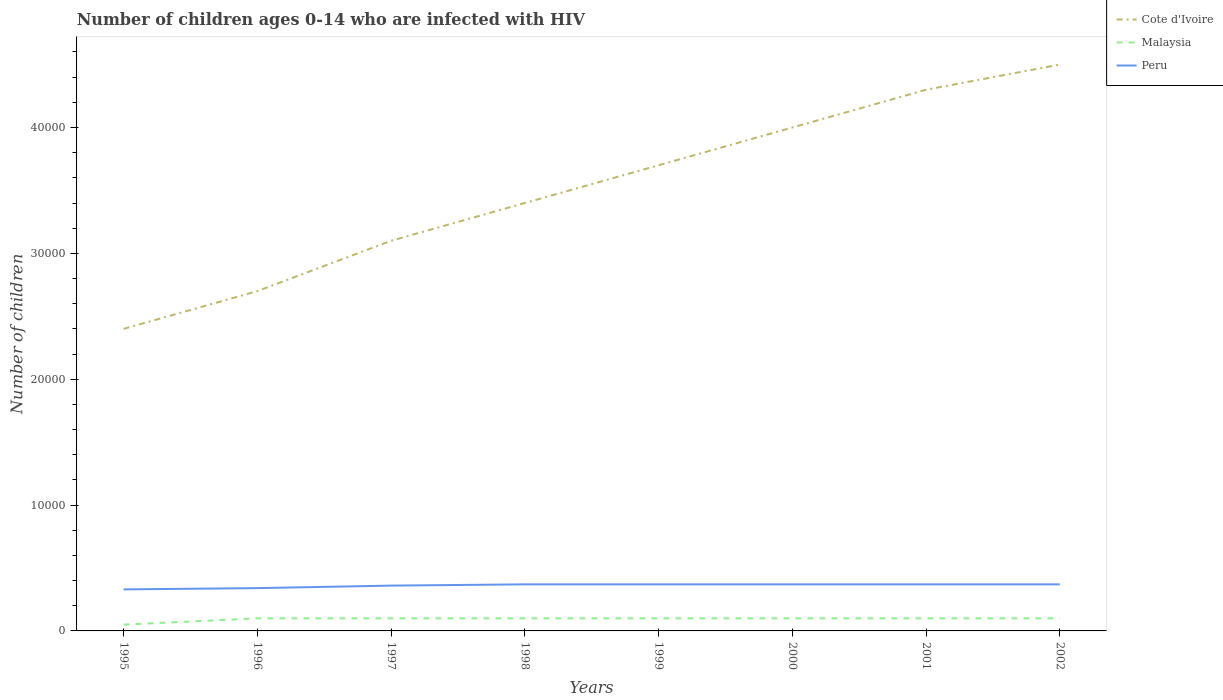Does the line corresponding to Peru intersect with the line corresponding to Cote d'Ivoire?
Your response must be concise. No. Across all years, what is the maximum number of HIV infected children in Peru?
Your response must be concise. 3300. What is the total number of HIV infected children in Peru in the graph?
Make the answer very short. -300. What is the difference between the highest and the second highest number of HIV infected children in Malaysia?
Make the answer very short. 500. What is the difference between the highest and the lowest number of HIV infected children in Peru?
Provide a succinct answer. 5. Is the number of HIV infected children in Peru strictly greater than the number of HIV infected children in Cote d'Ivoire over the years?
Make the answer very short. Yes. Are the values on the major ticks of Y-axis written in scientific E-notation?
Your answer should be compact. No. Does the graph contain any zero values?
Your response must be concise. No. Does the graph contain grids?
Your answer should be very brief. No. Where does the legend appear in the graph?
Offer a terse response. Top right. What is the title of the graph?
Your answer should be very brief. Number of children ages 0-14 who are infected with HIV. What is the label or title of the X-axis?
Your response must be concise. Years. What is the label or title of the Y-axis?
Provide a succinct answer. Number of children. What is the Number of children in Cote d'Ivoire in 1995?
Your answer should be compact. 2.40e+04. What is the Number of children of Malaysia in 1995?
Your answer should be very brief. 500. What is the Number of children in Peru in 1995?
Your answer should be compact. 3300. What is the Number of children in Cote d'Ivoire in 1996?
Your answer should be very brief. 2.70e+04. What is the Number of children of Peru in 1996?
Make the answer very short. 3400. What is the Number of children of Cote d'Ivoire in 1997?
Keep it short and to the point. 3.10e+04. What is the Number of children in Peru in 1997?
Give a very brief answer. 3600. What is the Number of children of Cote d'Ivoire in 1998?
Give a very brief answer. 3.40e+04. What is the Number of children of Peru in 1998?
Your answer should be compact. 3700. What is the Number of children of Cote d'Ivoire in 1999?
Provide a succinct answer. 3.70e+04. What is the Number of children in Malaysia in 1999?
Offer a very short reply. 1000. What is the Number of children in Peru in 1999?
Provide a short and direct response. 3700. What is the Number of children of Malaysia in 2000?
Give a very brief answer. 1000. What is the Number of children of Peru in 2000?
Your answer should be compact. 3700. What is the Number of children in Cote d'Ivoire in 2001?
Offer a terse response. 4.30e+04. What is the Number of children in Peru in 2001?
Your answer should be compact. 3700. What is the Number of children in Cote d'Ivoire in 2002?
Make the answer very short. 4.50e+04. What is the Number of children in Peru in 2002?
Offer a terse response. 3700. Across all years, what is the maximum Number of children in Cote d'Ivoire?
Your answer should be compact. 4.50e+04. Across all years, what is the maximum Number of children in Malaysia?
Make the answer very short. 1000. Across all years, what is the maximum Number of children in Peru?
Make the answer very short. 3700. Across all years, what is the minimum Number of children in Cote d'Ivoire?
Your answer should be very brief. 2.40e+04. Across all years, what is the minimum Number of children of Peru?
Provide a succinct answer. 3300. What is the total Number of children of Cote d'Ivoire in the graph?
Provide a short and direct response. 2.81e+05. What is the total Number of children in Malaysia in the graph?
Your answer should be very brief. 7500. What is the total Number of children in Peru in the graph?
Provide a succinct answer. 2.88e+04. What is the difference between the Number of children in Cote d'Ivoire in 1995 and that in 1996?
Give a very brief answer. -3000. What is the difference between the Number of children in Malaysia in 1995 and that in 1996?
Your answer should be compact. -500. What is the difference between the Number of children of Peru in 1995 and that in 1996?
Offer a very short reply. -100. What is the difference between the Number of children in Cote d'Ivoire in 1995 and that in 1997?
Make the answer very short. -7000. What is the difference between the Number of children of Malaysia in 1995 and that in 1997?
Your answer should be compact. -500. What is the difference between the Number of children of Peru in 1995 and that in 1997?
Give a very brief answer. -300. What is the difference between the Number of children in Cote d'Ivoire in 1995 and that in 1998?
Make the answer very short. -10000. What is the difference between the Number of children in Malaysia in 1995 and that in 1998?
Ensure brevity in your answer.  -500. What is the difference between the Number of children in Peru in 1995 and that in 1998?
Ensure brevity in your answer.  -400. What is the difference between the Number of children of Cote d'Ivoire in 1995 and that in 1999?
Provide a short and direct response. -1.30e+04. What is the difference between the Number of children in Malaysia in 1995 and that in 1999?
Provide a short and direct response. -500. What is the difference between the Number of children of Peru in 1995 and that in 1999?
Offer a terse response. -400. What is the difference between the Number of children in Cote d'Ivoire in 1995 and that in 2000?
Keep it short and to the point. -1.60e+04. What is the difference between the Number of children of Malaysia in 1995 and that in 2000?
Keep it short and to the point. -500. What is the difference between the Number of children of Peru in 1995 and that in 2000?
Provide a short and direct response. -400. What is the difference between the Number of children in Cote d'Ivoire in 1995 and that in 2001?
Keep it short and to the point. -1.90e+04. What is the difference between the Number of children of Malaysia in 1995 and that in 2001?
Give a very brief answer. -500. What is the difference between the Number of children in Peru in 1995 and that in 2001?
Provide a short and direct response. -400. What is the difference between the Number of children in Cote d'Ivoire in 1995 and that in 2002?
Offer a terse response. -2.10e+04. What is the difference between the Number of children in Malaysia in 1995 and that in 2002?
Keep it short and to the point. -500. What is the difference between the Number of children of Peru in 1995 and that in 2002?
Offer a terse response. -400. What is the difference between the Number of children in Cote d'Ivoire in 1996 and that in 1997?
Keep it short and to the point. -4000. What is the difference between the Number of children in Malaysia in 1996 and that in 1997?
Give a very brief answer. 0. What is the difference between the Number of children in Peru in 1996 and that in 1997?
Make the answer very short. -200. What is the difference between the Number of children of Cote d'Ivoire in 1996 and that in 1998?
Your answer should be very brief. -7000. What is the difference between the Number of children of Peru in 1996 and that in 1998?
Your answer should be very brief. -300. What is the difference between the Number of children in Peru in 1996 and that in 1999?
Provide a succinct answer. -300. What is the difference between the Number of children in Cote d'Ivoire in 1996 and that in 2000?
Keep it short and to the point. -1.30e+04. What is the difference between the Number of children in Malaysia in 1996 and that in 2000?
Your response must be concise. 0. What is the difference between the Number of children of Peru in 1996 and that in 2000?
Your response must be concise. -300. What is the difference between the Number of children of Cote d'Ivoire in 1996 and that in 2001?
Your answer should be very brief. -1.60e+04. What is the difference between the Number of children in Peru in 1996 and that in 2001?
Your answer should be very brief. -300. What is the difference between the Number of children of Cote d'Ivoire in 1996 and that in 2002?
Ensure brevity in your answer.  -1.80e+04. What is the difference between the Number of children of Peru in 1996 and that in 2002?
Keep it short and to the point. -300. What is the difference between the Number of children of Cote d'Ivoire in 1997 and that in 1998?
Your answer should be compact. -3000. What is the difference between the Number of children in Malaysia in 1997 and that in 1998?
Make the answer very short. 0. What is the difference between the Number of children in Peru in 1997 and that in 1998?
Provide a short and direct response. -100. What is the difference between the Number of children in Cote d'Ivoire in 1997 and that in 1999?
Keep it short and to the point. -6000. What is the difference between the Number of children of Malaysia in 1997 and that in 1999?
Provide a succinct answer. 0. What is the difference between the Number of children of Peru in 1997 and that in 1999?
Ensure brevity in your answer.  -100. What is the difference between the Number of children in Cote d'Ivoire in 1997 and that in 2000?
Keep it short and to the point. -9000. What is the difference between the Number of children in Peru in 1997 and that in 2000?
Ensure brevity in your answer.  -100. What is the difference between the Number of children in Cote d'Ivoire in 1997 and that in 2001?
Keep it short and to the point. -1.20e+04. What is the difference between the Number of children in Peru in 1997 and that in 2001?
Your response must be concise. -100. What is the difference between the Number of children of Cote d'Ivoire in 1997 and that in 2002?
Keep it short and to the point. -1.40e+04. What is the difference between the Number of children of Malaysia in 1997 and that in 2002?
Your answer should be compact. 0. What is the difference between the Number of children of Peru in 1997 and that in 2002?
Make the answer very short. -100. What is the difference between the Number of children in Cote d'Ivoire in 1998 and that in 1999?
Provide a succinct answer. -3000. What is the difference between the Number of children of Malaysia in 1998 and that in 1999?
Give a very brief answer. 0. What is the difference between the Number of children in Peru in 1998 and that in 1999?
Provide a succinct answer. 0. What is the difference between the Number of children of Cote d'Ivoire in 1998 and that in 2000?
Your answer should be compact. -6000. What is the difference between the Number of children in Peru in 1998 and that in 2000?
Provide a succinct answer. 0. What is the difference between the Number of children of Cote d'Ivoire in 1998 and that in 2001?
Provide a succinct answer. -9000. What is the difference between the Number of children in Malaysia in 1998 and that in 2001?
Offer a terse response. 0. What is the difference between the Number of children in Cote d'Ivoire in 1998 and that in 2002?
Keep it short and to the point. -1.10e+04. What is the difference between the Number of children in Malaysia in 1998 and that in 2002?
Offer a very short reply. 0. What is the difference between the Number of children in Cote d'Ivoire in 1999 and that in 2000?
Make the answer very short. -3000. What is the difference between the Number of children of Peru in 1999 and that in 2000?
Offer a very short reply. 0. What is the difference between the Number of children of Cote d'Ivoire in 1999 and that in 2001?
Offer a very short reply. -6000. What is the difference between the Number of children in Malaysia in 1999 and that in 2001?
Your response must be concise. 0. What is the difference between the Number of children in Peru in 1999 and that in 2001?
Make the answer very short. 0. What is the difference between the Number of children of Cote d'Ivoire in 1999 and that in 2002?
Provide a short and direct response. -8000. What is the difference between the Number of children of Peru in 1999 and that in 2002?
Ensure brevity in your answer.  0. What is the difference between the Number of children of Cote d'Ivoire in 2000 and that in 2001?
Provide a succinct answer. -3000. What is the difference between the Number of children of Malaysia in 2000 and that in 2001?
Offer a terse response. 0. What is the difference between the Number of children in Cote d'Ivoire in 2000 and that in 2002?
Provide a short and direct response. -5000. What is the difference between the Number of children of Malaysia in 2000 and that in 2002?
Keep it short and to the point. 0. What is the difference between the Number of children of Peru in 2000 and that in 2002?
Give a very brief answer. 0. What is the difference between the Number of children in Cote d'Ivoire in 2001 and that in 2002?
Ensure brevity in your answer.  -2000. What is the difference between the Number of children of Peru in 2001 and that in 2002?
Give a very brief answer. 0. What is the difference between the Number of children of Cote d'Ivoire in 1995 and the Number of children of Malaysia in 1996?
Provide a succinct answer. 2.30e+04. What is the difference between the Number of children of Cote d'Ivoire in 1995 and the Number of children of Peru in 1996?
Your answer should be very brief. 2.06e+04. What is the difference between the Number of children of Malaysia in 1995 and the Number of children of Peru in 1996?
Offer a terse response. -2900. What is the difference between the Number of children of Cote d'Ivoire in 1995 and the Number of children of Malaysia in 1997?
Provide a succinct answer. 2.30e+04. What is the difference between the Number of children of Cote d'Ivoire in 1995 and the Number of children of Peru in 1997?
Provide a short and direct response. 2.04e+04. What is the difference between the Number of children of Malaysia in 1995 and the Number of children of Peru in 1997?
Your answer should be very brief. -3100. What is the difference between the Number of children of Cote d'Ivoire in 1995 and the Number of children of Malaysia in 1998?
Ensure brevity in your answer.  2.30e+04. What is the difference between the Number of children in Cote d'Ivoire in 1995 and the Number of children in Peru in 1998?
Offer a terse response. 2.03e+04. What is the difference between the Number of children of Malaysia in 1995 and the Number of children of Peru in 1998?
Ensure brevity in your answer.  -3200. What is the difference between the Number of children in Cote d'Ivoire in 1995 and the Number of children in Malaysia in 1999?
Offer a very short reply. 2.30e+04. What is the difference between the Number of children of Cote d'Ivoire in 1995 and the Number of children of Peru in 1999?
Your answer should be very brief. 2.03e+04. What is the difference between the Number of children of Malaysia in 1995 and the Number of children of Peru in 1999?
Your answer should be compact. -3200. What is the difference between the Number of children of Cote d'Ivoire in 1995 and the Number of children of Malaysia in 2000?
Offer a terse response. 2.30e+04. What is the difference between the Number of children in Cote d'Ivoire in 1995 and the Number of children in Peru in 2000?
Your answer should be very brief. 2.03e+04. What is the difference between the Number of children of Malaysia in 1995 and the Number of children of Peru in 2000?
Your answer should be very brief. -3200. What is the difference between the Number of children of Cote d'Ivoire in 1995 and the Number of children of Malaysia in 2001?
Your answer should be compact. 2.30e+04. What is the difference between the Number of children of Cote d'Ivoire in 1995 and the Number of children of Peru in 2001?
Provide a short and direct response. 2.03e+04. What is the difference between the Number of children in Malaysia in 1995 and the Number of children in Peru in 2001?
Give a very brief answer. -3200. What is the difference between the Number of children in Cote d'Ivoire in 1995 and the Number of children in Malaysia in 2002?
Provide a short and direct response. 2.30e+04. What is the difference between the Number of children in Cote d'Ivoire in 1995 and the Number of children in Peru in 2002?
Your answer should be very brief. 2.03e+04. What is the difference between the Number of children in Malaysia in 1995 and the Number of children in Peru in 2002?
Your answer should be compact. -3200. What is the difference between the Number of children in Cote d'Ivoire in 1996 and the Number of children in Malaysia in 1997?
Offer a very short reply. 2.60e+04. What is the difference between the Number of children of Cote d'Ivoire in 1996 and the Number of children of Peru in 1997?
Ensure brevity in your answer.  2.34e+04. What is the difference between the Number of children of Malaysia in 1996 and the Number of children of Peru in 1997?
Provide a succinct answer. -2600. What is the difference between the Number of children of Cote d'Ivoire in 1996 and the Number of children of Malaysia in 1998?
Ensure brevity in your answer.  2.60e+04. What is the difference between the Number of children in Cote d'Ivoire in 1996 and the Number of children in Peru in 1998?
Keep it short and to the point. 2.33e+04. What is the difference between the Number of children of Malaysia in 1996 and the Number of children of Peru in 1998?
Provide a short and direct response. -2700. What is the difference between the Number of children of Cote d'Ivoire in 1996 and the Number of children of Malaysia in 1999?
Ensure brevity in your answer.  2.60e+04. What is the difference between the Number of children in Cote d'Ivoire in 1996 and the Number of children in Peru in 1999?
Give a very brief answer. 2.33e+04. What is the difference between the Number of children of Malaysia in 1996 and the Number of children of Peru in 1999?
Your response must be concise. -2700. What is the difference between the Number of children in Cote d'Ivoire in 1996 and the Number of children in Malaysia in 2000?
Your answer should be very brief. 2.60e+04. What is the difference between the Number of children in Cote d'Ivoire in 1996 and the Number of children in Peru in 2000?
Your answer should be very brief. 2.33e+04. What is the difference between the Number of children in Malaysia in 1996 and the Number of children in Peru in 2000?
Your answer should be compact. -2700. What is the difference between the Number of children of Cote d'Ivoire in 1996 and the Number of children of Malaysia in 2001?
Offer a very short reply. 2.60e+04. What is the difference between the Number of children of Cote d'Ivoire in 1996 and the Number of children of Peru in 2001?
Keep it short and to the point. 2.33e+04. What is the difference between the Number of children in Malaysia in 1996 and the Number of children in Peru in 2001?
Provide a succinct answer. -2700. What is the difference between the Number of children of Cote d'Ivoire in 1996 and the Number of children of Malaysia in 2002?
Your response must be concise. 2.60e+04. What is the difference between the Number of children of Cote d'Ivoire in 1996 and the Number of children of Peru in 2002?
Make the answer very short. 2.33e+04. What is the difference between the Number of children of Malaysia in 1996 and the Number of children of Peru in 2002?
Ensure brevity in your answer.  -2700. What is the difference between the Number of children in Cote d'Ivoire in 1997 and the Number of children in Malaysia in 1998?
Give a very brief answer. 3.00e+04. What is the difference between the Number of children in Cote d'Ivoire in 1997 and the Number of children in Peru in 1998?
Your answer should be compact. 2.73e+04. What is the difference between the Number of children of Malaysia in 1997 and the Number of children of Peru in 1998?
Offer a very short reply. -2700. What is the difference between the Number of children in Cote d'Ivoire in 1997 and the Number of children in Malaysia in 1999?
Keep it short and to the point. 3.00e+04. What is the difference between the Number of children in Cote d'Ivoire in 1997 and the Number of children in Peru in 1999?
Offer a very short reply. 2.73e+04. What is the difference between the Number of children in Malaysia in 1997 and the Number of children in Peru in 1999?
Your answer should be very brief. -2700. What is the difference between the Number of children in Cote d'Ivoire in 1997 and the Number of children in Peru in 2000?
Give a very brief answer. 2.73e+04. What is the difference between the Number of children of Malaysia in 1997 and the Number of children of Peru in 2000?
Provide a short and direct response. -2700. What is the difference between the Number of children in Cote d'Ivoire in 1997 and the Number of children in Malaysia in 2001?
Ensure brevity in your answer.  3.00e+04. What is the difference between the Number of children of Cote d'Ivoire in 1997 and the Number of children of Peru in 2001?
Give a very brief answer. 2.73e+04. What is the difference between the Number of children of Malaysia in 1997 and the Number of children of Peru in 2001?
Your answer should be very brief. -2700. What is the difference between the Number of children in Cote d'Ivoire in 1997 and the Number of children in Malaysia in 2002?
Ensure brevity in your answer.  3.00e+04. What is the difference between the Number of children in Cote d'Ivoire in 1997 and the Number of children in Peru in 2002?
Offer a very short reply. 2.73e+04. What is the difference between the Number of children of Malaysia in 1997 and the Number of children of Peru in 2002?
Your answer should be very brief. -2700. What is the difference between the Number of children of Cote d'Ivoire in 1998 and the Number of children of Malaysia in 1999?
Give a very brief answer. 3.30e+04. What is the difference between the Number of children of Cote d'Ivoire in 1998 and the Number of children of Peru in 1999?
Your answer should be very brief. 3.03e+04. What is the difference between the Number of children in Malaysia in 1998 and the Number of children in Peru in 1999?
Your answer should be very brief. -2700. What is the difference between the Number of children of Cote d'Ivoire in 1998 and the Number of children of Malaysia in 2000?
Give a very brief answer. 3.30e+04. What is the difference between the Number of children of Cote d'Ivoire in 1998 and the Number of children of Peru in 2000?
Make the answer very short. 3.03e+04. What is the difference between the Number of children in Malaysia in 1998 and the Number of children in Peru in 2000?
Make the answer very short. -2700. What is the difference between the Number of children in Cote d'Ivoire in 1998 and the Number of children in Malaysia in 2001?
Your answer should be compact. 3.30e+04. What is the difference between the Number of children in Cote d'Ivoire in 1998 and the Number of children in Peru in 2001?
Offer a terse response. 3.03e+04. What is the difference between the Number of children of Malaysia in 1998 and the Number of children of Peru in 2001?
Offer a terse response. -2700. What is the difference between the Number of children of Cote d'Ivoire in 1998 and the Number of children of Malaysia in 2002?
Keep it short and to the point. 3.30e+04. What is the difference between the Number of children in Cote d'Ivoire in 1998 and the Number of children in Peru in 2002?
Keep it short and to the point. 3.03e+04. What is the difference between the Number of children in Malaysia in 1998 and the Number of children in Peru in 2002?
Offer a very short reply. -2700. What is the difference between the Number of children in Cote d'Ivoire in 1999 and the Number of children in Malaysia in 2000?
Your answer should be compact. 3.60e+04. What is the difference between the Number of children in Cote d'Ivoire in 1999 and the Number of children in Peru in 2000?
Your answer should be compact. 3.33e+04. What is the difference between the Number of children in Malaysia in 1999 and the Number of children in Peru in 2000?
Your answer should be compact. -2700. What is the difference between the Number of children in Cote d'Ivoire in 1999 and the Number of children in Malaysia in 2001?
Your answer should be very brief. 3.60e+04. What is the difference between the Number of children of Cote d'Ivoire in 1999 and the Number of children of Peru in 2001?
Your response must be concise. 3.33e+04. What is the difference between the Number of children in Malaysia in 1999 and the Number of children in Peru in 2001?
Provide a short and direct response. -2700. What is the difference between the Number of children of Cote d'Ivoire in 1999 and the Number of children of Malaysia in 2002?
Offer a terse response. 3.60e+04. What is the difference between the Number of children of Cote d'Ivoire in 1999 and the Number of children of Peru in 2002?
Offer a very short reply. 3.33e+04. What is the difference between the Number of children in Malaysia in 1999 and the Number of children in Peru in 2002?
Offer a very short reply. -2700. What is the difference between the Number of children in Cote d'Ivoire in 2000 and the Number of children in Malaysia in 2001?
Your answer should be very brief. 3.90e+04. What is the difference between the Number of children in Cote d'Ivoire in 2000 and the Number of children in Peru in 2001?
Your answer should be compact. 3.63e+04. What is the difference between the Number of children of Malaysia in 2000 and the Number of children of Peru in 2001?
Your answer should be very brief. -2700. What is the difference between the Number of children in Cote d'Ivoire in 2000 and the Number of children in Malaysia in 2002?
Keep it short and to the point. 3.90e+04. What is the difference between the Number of children in Cote d'Ivoire in 2000 and the Number of children in Peru in 2002?
Your response must be concise. 3.63e+04. What is the difference between the Number of children in Malaysia in 2000 and the Number of children in Peru in 2002?
Your answer should be very brief. -2700. What is the difference between the Number of children in Cote d'Ivoire in 2001 and the Number of children in Malaysia in 2002?
Keep it short and to the point. 4.20e+04. What is the difference between the Number of children in Cote d'Ivoire in 2001 and the Number of children in Peru in 2002?
Your answer should be very brief. 3.93e+04. What is the difference between the Number of children of Malaysia in 2001 and the Number of children of Peru in 2002?
Ensure brevity in your answer.  -2700. What is the average Number of children of Cote d'Ivoire per year?
Your answer should be very brief. 3.51e+04. What is the average Number of children of Malaysia per year?
Provide a succinct answer. 937.5. What is the average Number of children of Peru per year?
Provide a short and direct response. 3600. In the year 1995, what is the difference between the Number of children in Cote d'Ivoire and Number of children in Malaysia?
Give a very brief answer. 2.35e+04. In the year 1995, what is the difference between the Number of children in Cote d'Ivoire and Number of children in Peru?
Offer a terse response. 2.07e+04. In the year 1995, what is the difference between the Number of children of Malaysia and Number of children of Peru?
Provide a succinct answer. -2800. In the year 1996, what is the difference between the Number of children in Cote d'Ivoire and Number of children in Malaysia?
Offer a terse response. 2.60e+04. In the year 1996, what is the difference between the Number of children in Cote d'Ivoire and Number of children in Peru?
Offer a very short reply. 2.36e+04. In the year 1996, what is the difference between the Number of children of Malaysia and Number of children of Peru?
Provide a succinct answer. -2400. In the year 1997, what is the difference between the Number of children of Cote d'Ivoire and Number of children of Malaysia?
Provide a short and direct response. 3.00e+04. In the year 1997, what is the difference between the Number of children in Cote d'Ivoire and Number of children in Peru?
Keep it short and to the point. 2.74e+04. In the year 1997, what is the difference between the Number of children in Malaysia and Number of children in Peru?
Provide a short and direct response. -2600. In the year 1998, what is the difference between the Number of children in Cote d'Ivoire and Number of children in Malaysia?
Provide a succinct answer. 3.30e+04. In the year 1998, what is the difference between the Number of children of Cote d'Ivoire and Number of children of Peru?
Ensure brevity in your answer.  3.03e+04. In the year 1998, what is the difference between the Number of children in Malaysia and Number of children in Peru?
Offer a very short reply. -2700. In the year 1999, what is the difference between the Number of children in Cote d'Ivoire and Number of children in Malaysia?
Your answer should be very brief. 3.60e+04. In the year 1999, what is the difference between the Number of children in Cote d'Ivoire and Number of children in Peru?
Offer a very short reply. 3.33e+04. In the year 1999, what is the difference between the Number of children of Malaysia and Number of children of Peru?
Your response must be concise. -2700. In the year 2000, what is the difference between the Number of children of Cote d'Ivoire and Number of children of Malaysia?
Keep it short and to the point. 3.90e+04. In the year 2000, what is the difference between the Number of children of Cote d'Ivoire and Number of children of Peru?
Provide a short and direct response. 3.63e+04. In the year 2000, what is the difference between the Number of children in Malaysia and Number of children in Peru?
Offer a very short reply. -2700. In the year 2001, what is the difference between the Number of children of Cote d'Ivoire and Number of children of Malaysia?
Make the answer very short. 4.20e+04. In the year 2001, what is the difference between the Number of children of Cote d'Ivoire and Number of children of Peru?
Keep it short and to the point. 3.93e+04. In the year 2001, what is the difference between the Number of children of Malaysia and Number of children of Peru?
Offer a very short reply. -2700. In the year 2002, what is the difference between the Number of children of Cote d'Ivoire and Number of children of Malaysia?
Provide a succinct answer. 4.40e+04. In the year 2002, what is the difference between the Number of children of Cote d'Ivoire and Number of children of Peru?
Make the answer very short. 4.13e+04. In the year 2002, what is the difference between the Number of children in Malaysia and Number of children in Peru?
Give a very brief answer. -2700. What is the ratio of the Number of children of Cote d'Ivoire in 1995 to that in 1996?
Provide a succinct answer. 0.89. What is the ratio of the Number of children in Malaysia in 1995 to that in 1996?
Provide a succinct answer. 0.5. What is the ratio of the Number of children in Peru in 1995 to that in 1996?
Keep it short and to the point. 0.97. What is the ratio of the Number of children of Cote d'Ivoire in 1995 to that in 1997?
Give a very brief answer. 0.77. What is the ratio of the Number of children in Malaysia in 1995 to that in 1997?
Provide a short and direct response. 0.5. What is the ratio of the Number of children in Peru in 1995 to that in 1997?
Ensure brevity in your answer.  0.92. What is the ratio of the Number of children of Cote d'Ivoire in 1995 to that in 1998?
Offer a very short reply. 0.71. What is the ratio of the Number of children in Malaysia in 1995 to that in 1998?
Provide a succinct answer. 0.5. What is the ratio of the Number of children in Peru in 1995 to that in 1998?
Provide a short and direct response. 0.89. What is the ratio of the Number of children in Cote d'Ivoire in 1995 to that in 1999?
Your answer should be compact. 0.65. What is the ratio of the Number of children in Malaysia in 1995 to that in 1999?
Provide a short and direct response. 0.5. What is the ratio of the Number of children in Peru in 1995 to that in 1999?
Your response must be concise. 0.89. What is the ratio of the Number of children of Peru in 1995 to that in 2000?
Give a very brief answer. 0.89. What is the ratio of the Number of children of Cote d'Ivoire in 1995 to that in 2001?
Ensure brevity in your answer.  0.56. What is the ratio of the Number of children of Peru in 1995 to that in 2001?
Make the answer very short. 0.89. What is the ratio of the Number of children of Cote d'Ivoire in 1995 to that in 2002?
Ensure brevity in your answer.  0.53. What is the ratio of the Number of children of Peru in 1995 to that in 2002?
Provide a succinct answer. 0.89. What is the ratio of the Number of children in Cote d'Ivoire in 1996 to that in 1997?
Your response must be concise. 0.87. What is the ratio of the Number of children of Malaysia in 1996 to that in 1997?
Make the answer very short. 1. What is the ratio of the Number of children in Cote d'Ivoire in 1996 to that in 1998?
Your response must be concise. 0.79. What is the ratio of the Number of children in Malaysia in 1996 to that in 1998?
Your answer should be compact. 1. What is the ratio of the Number of children in Peru in 1996 to that in 1998?
Provide a short and direct response. 0.92. What is the ratio of the Number of children of Cote d'Ivoire in 1996 to that in 1999?
Give a very brief answer. 0.73. What is the ratio of the Number of children in Peru in 1996 to that in 1999?
Your answer should be very brief. 0.92. What is the ratio of the Number of children of Cote d'Ivoire in 1996 to that in 2000?
Give a very brief answer. 0.68. What is the ratio of the Number of children of Peru in 1996 to that in 2000?
Your response must be concise. 0.92. What is the ratio of the Number of children in Cote d'Ivoire in 1996 to that in 2001?
Offer a terse response. 0.63. What is the ratio of the Number of children of Malaysia in 1996 to that in 2001?
Provide a succinct answer. 1. What is the ratio of the Number of children in Peru in 1996 to that in 2001?
Your answer should be very brief. 0.92. What is the ratio of the Number of children in Cote d'Ivoire in 1996 to that in 2002?
Your answer should be very brief. 0.6. What is the ratio of the Number of children in Peru in 1996 to that in 2002?
Offer a terse response. 0.92. What is the ratio of the Number of children in Cote d'Ivoire in 1997 to that in 1998?
Offer a very short reply. 0.91. What is the ratio of the Number of children in Cote d'Ivoire in 1997 to that in 1999?
Give a very brief answer. 0.84. What is the ratio of the Number of children in Peru in 1997 to that in 1999?
Your answer should be compact. 0.97. What is the ratio of the Number of children of Cote d'Ivoire in 1997 to that in 2000?
Provide a succinct answer. 0.78. What is the ratio of the Number of children in Cote d'Ivoire in 1997 to that in 2001?
Your answer should be compact. 0.72. What is the ratio of the Number of children of Malaysia in 1997 to that in 2001?
Provide a succinct answer. 1. What is the ratio of the Number of children in Peru in 1997 to that in 2001?
Offer a terse response. 0.97. What is the ratio of the Number of children of Cote d'Ivoire in 1997 to that in 2002?
Make the answer very short. 0.69. What is the ratio of the Number of children in Cote d'Ivoire in 1998 to that in 1999?
Make the answer very short. 0.92. What is the ratio of the Number of children in Peru in 1998 to that in 1999?
Ensure brevity in your answer.  1. What is the ratio of the Number of children in Cote d'Ivoire in 1998 to that in 2001?
Your answer should be very brief. 0.79. What is the ratio of the Number of children in Malaysia in 1998 to that in 2001?
Provide a short and direct response. 1. What is the ratio of the Number of children in Peru in 1998 to that in 2001?
Ensure brevity in your answer.  1. What is the ratio of the Number of children of Cote d'Ivoire in 1998 to that in 2002?
Provide a succinct answer. 0.76. What is the ratio of the Number of children in Peru in 1998 to that in 2002?
Make the answer very short. 1. What is the ratio of the Number of children in Cote d'Ivoire in 1999 to that in 2000?
Your answer should be compact. 0.93. What is the ratio of the Number of children in Peru in 1999 to that in 2000?
Provide a succinct answer. 1. What is the ratio of the Number of children in Cote d'Ivoire in 1999 to that in 2001?
Provide a short and direct response. 0.86. What is the ratio of the Number of children in Peru in 1999 to that in 2001?
Make the answer very short. 1. What is the ratio of the Number of children of Cote d'Ivoire in 1999 to that in 2002?
Make the answer very short. 0.82. What is the ratio of the Number of children in Peru in 1999 to that in 2002?
Provide a short and direct response. 1. What is the ratio of the Number of children in Cote d'Ivoire in 2000 to that in 2001?
Give a very brief answer. 0.93. What is the ratio of the Number of children of Malaysia in 2000 to that in 2001?
Give a very brief answer. 1. What is the ratio of the Number of children of Peru in 2000 to that in 2001?
Make the answer very short. 1. What is the ratio of the Number of children of Malaysia in 2000 to that in 2002?
Offer a very short reply. 1. What is the ratio of the Number of children of Peru in 2000 to that in 2002?
Make the answer very short. 1. What is the ratio of the Number of children of Cote d'Ivoire in 2001 to that in 2002?
Provide a short and direct response. 0.96. What is the ratio of the Number of children of Malaysia in 2001 to that in 2002?
Your answer should be compact. 1. What is the ratio of the Number of children of Peru in 2001 to that in 2002?
Provide a succinct answer. 1. What is the difference between the highest and the second highest Number of children in Cote d'Ivoire?
Keep it short and to the point. 2000. What is the difference between the highest and the second highest Number of children in Malaysia?
Your answer should be compact. 0. What is the difference between the highest and the lowest Number of children of Cote d'Ivoire?
Your answer should be compact. 2.10e+04. What is the difference between the highest and the lowest Number of children in Malaysia?
Your response must be concise. 500. 